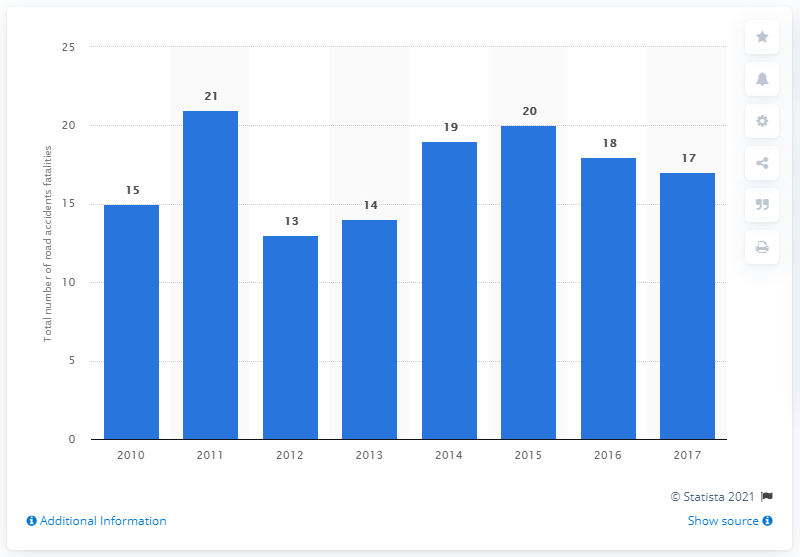Indicate a few pertinent items in this graphic. In 2011, the peak number of road accident fatalities in Curaao was 21. In 2017, there were 17 fatalities due to road accidents. 